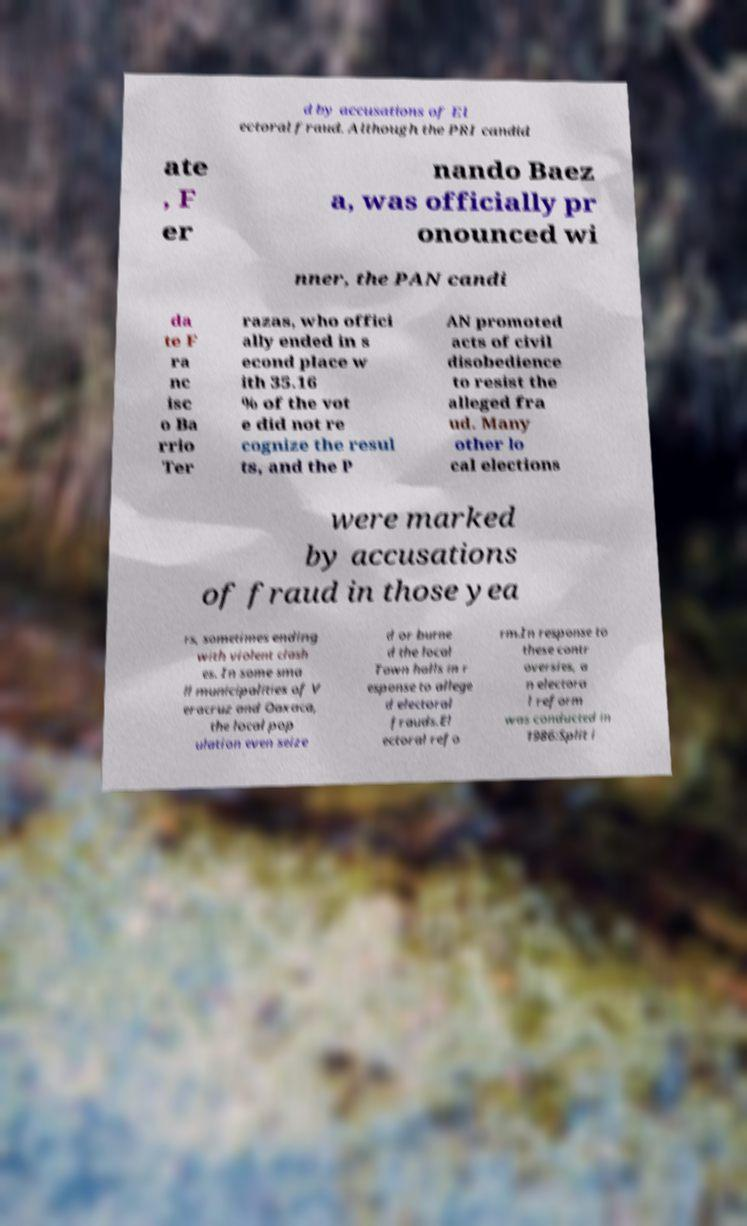Can you accurately transcribe the text from the provided image for me? d by accusations of El ectoral fraud. Although the PRI candid ate , F er nando Baez a, was officially pr onounced wi nner, the PAN candi da te F ra nc isc o Ba rrio Ter razas, who offici ally ended in s econd place w ith 35.16 % of the vot e did not re cognize the resul ts, and the P AN promoted acts of civil disobedience to resist the alleged fra ud. Many other lo cal elections were marked by accusations of fraud in those yea rs, sometimes ending with violent clash es. In some sma ll municipalities of V eracruz and Oaxaca, the local pop ulation even seize d or burne d the local Town halls in r esponse to allege d electoral frauds.El ectoral refo rm.In response to these contr oversies, a n electora l reform was conducted in 1986:Split i 